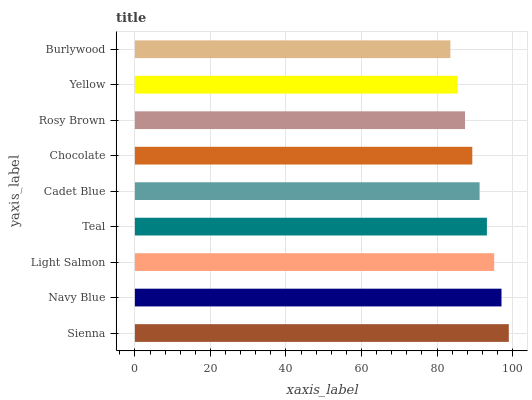Is Burlywood the minimum?
Answer yes or no. Yes. Is Sienna the maximum?
Answer yes or no. Yes. Is Navy Blue the minimum?
Answer yes or no. No. Is Navy Blue the maximum?
Answer yes or no. No. Is Sienna greater than Navy Blue?
Answer yes or no. Yes. Is Navy Blue less than Sienna?
Answer yes or no. Yes. Is Navy Blue greater than Sienna?
Answer yes or no. No. Is Sienna less than Navy Blue?
Answer yes or no. No. Is Cadet Blue the high median?
Answer yes or no. Yes. Is Cadet Blue the low median?
Answer yes or no. Yes. Is Yellow the high median?
Answer yes or no. No. Is Teal the low median?
Answer yes or no. No. 